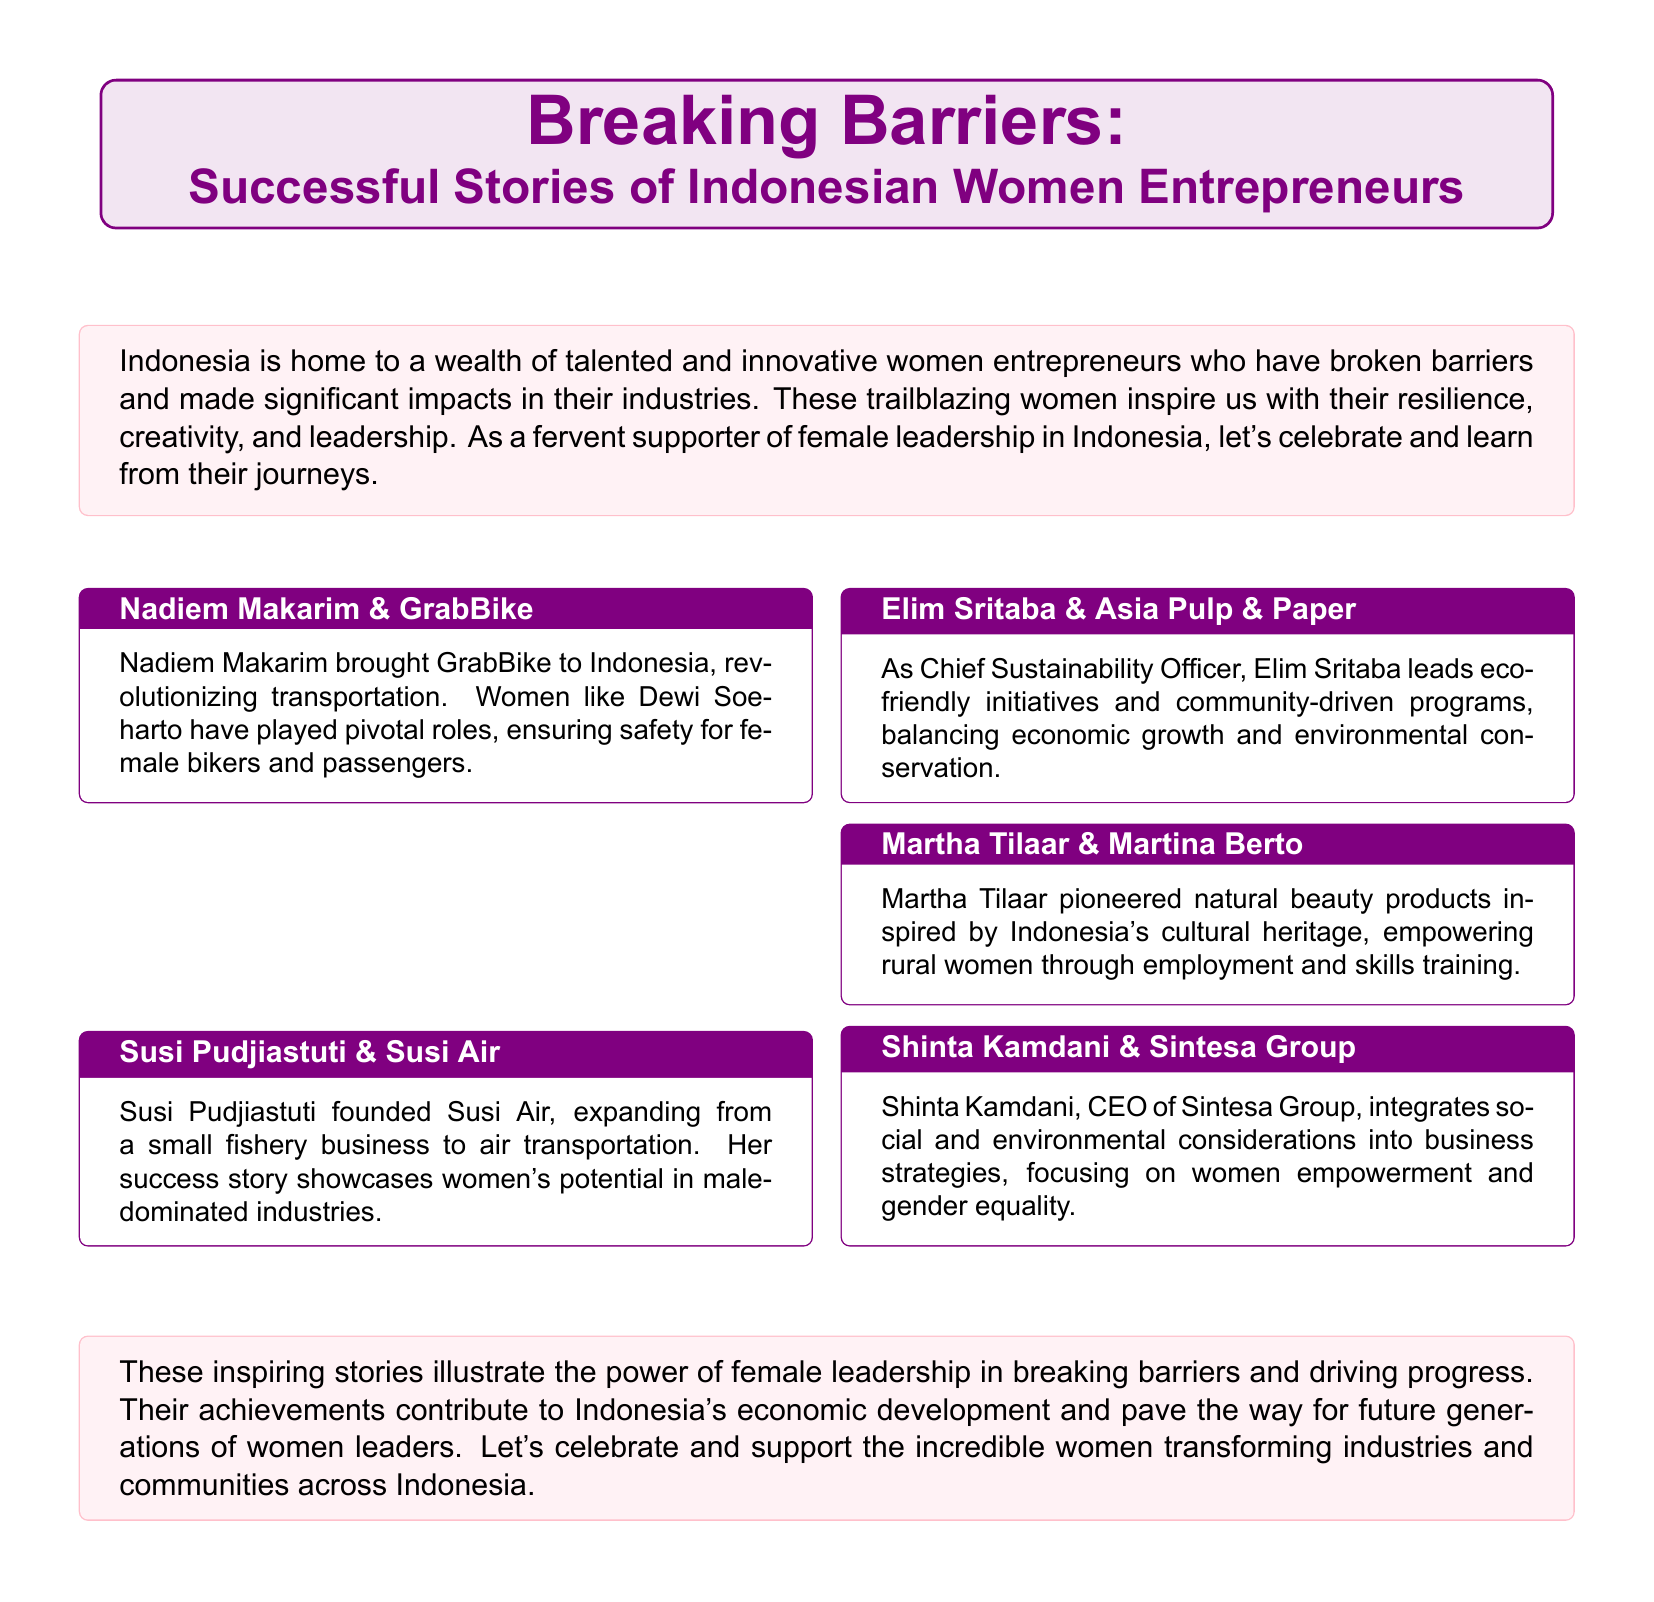What is the main topic of the flyer? The flyer discusses the journeys of women entrepreneurs in Indonesia.
Answer: Successful Stories of Indonesian Women Entrepreneurs Who founded Susi Air? The document names Susi Pudjiastuti as the founder of Susi Air.
Answer: Susi Pudjiastuti What industry is Nadiem Makarim associated with? The flyer mentions his contribution to the transportation industry through GrabBike.
Answer: Transportation Which entrepreneur focuses on eco-friendly initiatives? The document indicates that Elim Sritaba leads eco-friendly initiatives.
Answer: Elim Sritaba How does Martha Tilaar empower women? The flyer states that she empowers rural women through employment and skills training.
Answer: Employment and skills training What is the role of Shinta Kamdani in Sintesa Group? The document describes her as the CEO of Sintesa Group.
Answer: CEO What is the common theme among the stories shared in the flyer? The document emphasizes breaking barriers and promoting female leadership.
Answer: Breaking barriers Which color is used for the background of the title box? The flyer uses a light purple color for the title box background.
Answer: Light purple What term describes the content's impact on future generations? The document mentions that the achievements pave the way for future generations.
Answer: Pave the way 